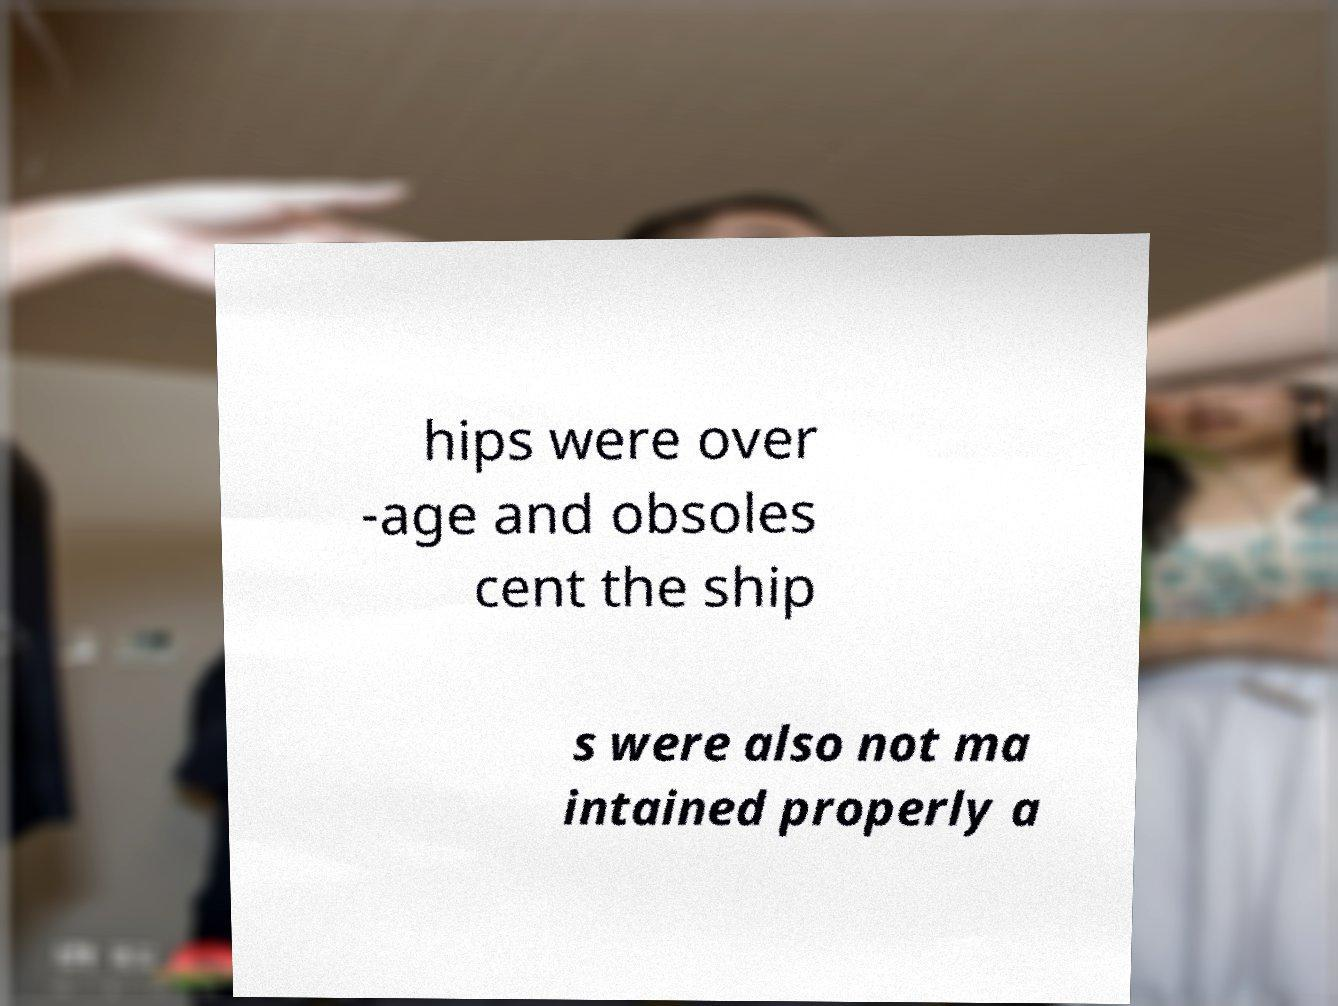What messages or text are displayed in this image? I need them in a readable, typed format. hips were over -age and obsoles cent the ship s were also not ma intained properly a 